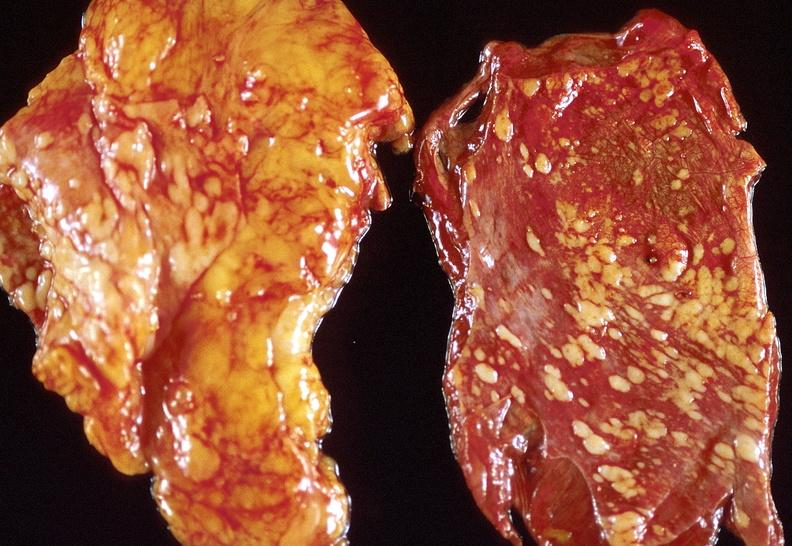does lesion cross show lung carcinoma?
Answer the question using a single word or phrase. No 